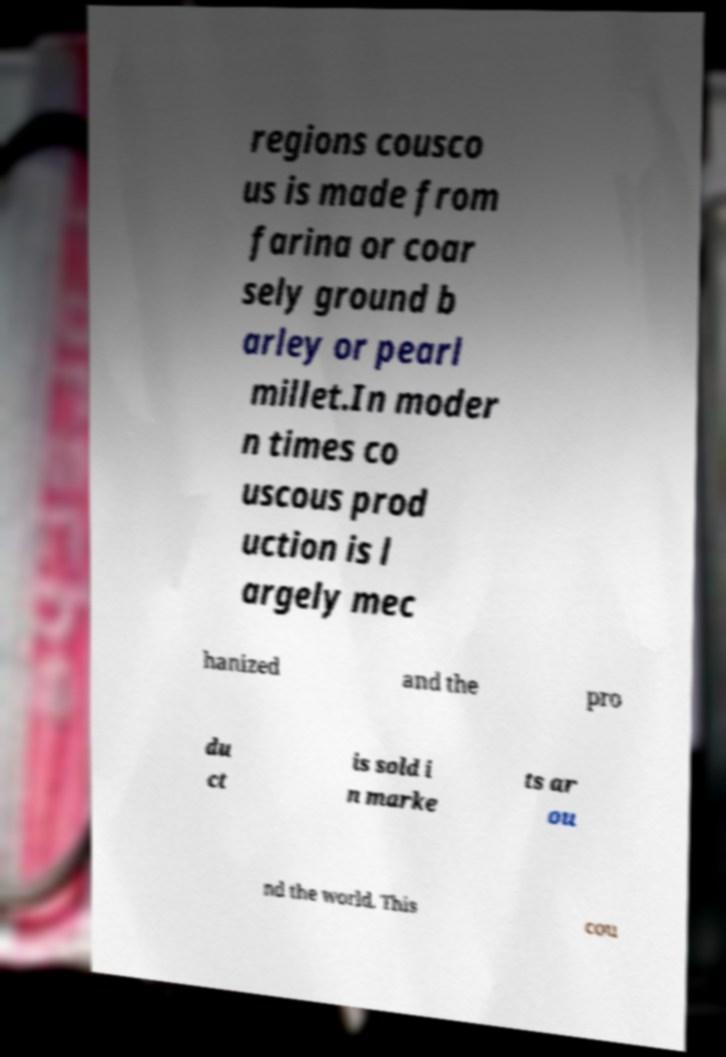Please identify and transcribe the text found in this image. regions cousco us is made from farina or coar sely ground b arley or pearl millet.In moder n times co uscous prod uction is l argely mec hanized and the pro du ct is sold i n marke ts ar ou nd the world. This cou 